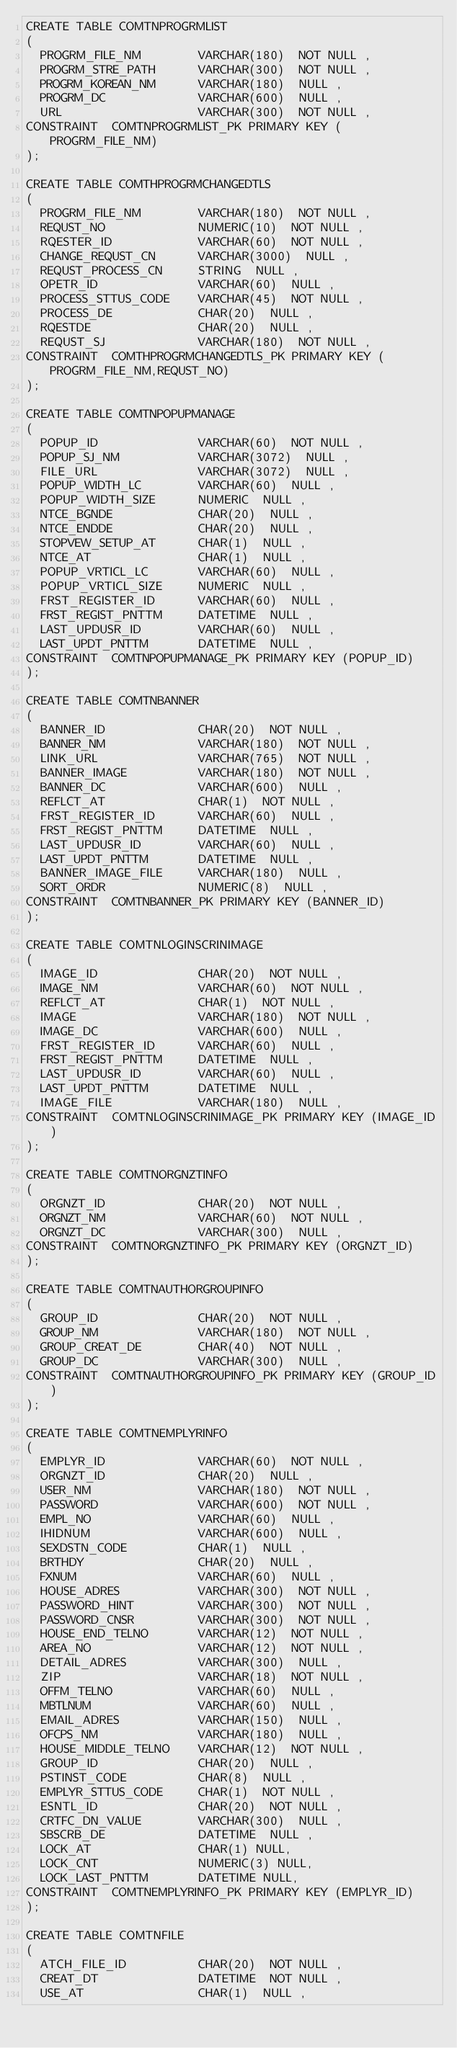<code> <loc_0><loc_0><loc_500><loc_500><_SQL_>CREATE TABLE COMTNPROGRMLIST
(
	PROGRM_FILE_NM        VARCHAR(180)  NOT NULL ,
	PROGRM_STRE_PATH      VARCHAR(300)  NOT NULL ,
	PROGRM_KOREAN_NM      VARCHAR(180)  NULL ,
	PROGRM_DC             VARCHAR(600)  NULL ,
	URL                   VARCHAR(300)  NOT NULL ,
CONSTRAINT  COMTNPROGRMLIST_PK PRIMARY KEY (PROGRM_FILE_NM)
);

CREATE TABLE COMTHPROGRMCHANGEDTLS
(
	PROGRM_FILE_NM        VARCHAR(180)  NOT NULL ,
	REQUST_NO             NUMERIC(10)  NOT NULL ,
	RQESTER_ID            VARCHAR(60)  NOT NULL ,
	CHANGE_REQUST_CN      VARCHAR(3000)  NULL ,
	REQUST_PROCESS_CN     STRING  NULL ,
	OPETR_ID              VARCHAR(60)  NULL ,
	PROCESS_STTUS_CODE    VARCHAR(45)  NOT NULL ,
	PROCESS_DE            CHAR(20)  NULL ,
	RQESTDE               CHAR(20)  NULL ,
	REQUST_SJ             VARCHAR(180)  NOT NULL ,
CONSTRAINT  COMTHPROGRMCHANGEDTLS_PK PRIMARY KEY (PROGRM_FILE_NM,REQUST_NO)
);

CREATE TABLE COMTNPOPUPMANAGE
(
	POPUP_ID              VARCHAR(60)  NOT NULL ,
	POPUP_SJ_NM           VARCHAR(3072)  NULL ,
	FILE_URL              VARCHAR(3072)  NULL ,
	POPUP_WIDTH_LC        VARCHAR(60)  NULL ,
	POPUP_WIDTH_SIZE      NUMERIC  NULL ,
	NTCE_BGNDE            CHAR(20)  NULL ,
	NTCE_ENDDE            CHAR(20)  NULL ,
	STOPVEW_SETUP_AT      CHAR(1)  NULL ,
	NTCE_AT               CHAR(1)  NULL ,
	POPUP_VRTICL_LC       VARCHAR(60)  NULL ,
	POPUP_VRTICL_SIZE     NUMERIC  NULL ,
	FRST_REGISTER_ID      VARCHAR(60)  NULL ,
	FRST_REGIST_PNTTM     DATETIME  NULL ,
	LAST_UPDUSR_ID        VARCHAR(60)  NULL ,
	LAST_UPDT_PNTTM       DATETIME  NULL ,
CONSTRAINT  COMTNPOPUPMANAGE_PK PRIMARY KEY (POPUP_ID)
);

CREATE TABLE COMTNBANNER
(
	BANNER_ID             CHAR(20)  NOT NULL ,
	BANNER_NM             VARCHAR(180)  NOT NULL ,
	LINK_URL              VARCHAR(765)  NOT NULL ,
	BANNER_IMAGE          VARCHAR(180)  NOT NULL ,
	BANNER_DC             VARCHAR(600)  NULL ,
	REFLCT_AT             CHAR(1)  NOT NULL ,
	FRST_REGISTER_ID      VARCHAR(60)  NULL ,
	FRST_REGIST_PNTTM     DATETIME  NULL ,
	LAST_UPDUSR_ID        VARCHAR(60)  NULL ,
	LAST_UPDT_PNTTM       DATETIME  NULL ,
	BANNER_IMAGE_FILE     VARCHAR(180)  NULL ,
	SORT_ORDR             NUMERIC(8)  NULL ,
CONSTRAINT  COMTNBANNER_PK PRIMARY KEY (BANNER_ID)
);

CREATE TABLE COMTNLOGINSCRINIMAGE
(
	IMAGE_ID              CHAR(20)  NOT NULL ,
	IMAGE_NM              VARCHAR(60)  NOT NULL ,
	REFLCT_AT             CHAR(1)  NOT NULL ,
	IMAGE                 VARCHAR(180)  NOT NULL ,
	IMAGE_DC              VARCHAR(600)  NULL ,
	FRST_REGISTER_ID      VARCHAR(60)  NULL ,
	FRST_REGIST_PNTTM     DATETIME  NULL ,
	LAST_UPDUSR_ID        VARCHAR(60)  NULL ,
	LAST_UPDT_PNTTM       DATETIME  NULL ,
	IMAGE_FILE            VARCHAR(180)  NULL ,
CONSTRAINT  COMTNLOGINSCRINIMAGE_PK PRIMARY KEY (IMAGE_ID)
);

CREATE TABLE COMTNORGNZTINFO
(
	ORGNZT_ID             CHAR(20)  NOT NULL ,
	ORGNZT_NM             VARCHAR(60)  NOT NULL ,
	ORGNZT_DC             VARCHAR(300)  NULL ,
CONSTRAINT  COMTNORGNZTINFO_PK PRIMARY KEY (ORGNZT_ID)
);

CREATE TABLE COMTNAUTHORGROUPINFO
(
	GROUP_ID              CHAR(20)  NOT NULL ,
	GROUP_NM              VARCHAR(180)  NOT NULL ,
	GROUP_CREAT_DE        CHAR(40)  NOT NULL ,
	GROUP_DC              VARCHAR(300)  NULL ,
CONSTRAINT  COMTNAUTHORGROUPINFO_PK PRIMARY KEY (GROUP_ID)
);

CREATE TABLE COMTNEMPLYRINFO
(
	EMPLYR_ID             VARCHAR(60)  NOT NULL ,
	ORGNZT_ID             CHAR(20)  NULL ,
	USER_NM               VARCHAR(180)  NOT NULL ,
	PASSWORD              VARCHAR(600)  NOT NULL ,
	EMPL_NO               VARCHAR(60)  NULL ,
	IHIDNUM               VARCHAR(600)  NULL ,
	SEXDSTN_CODE          CHAR(1)  NULL ,
	BRTHDY                CHAR(20)  NULL ,
	FXNUM                 VARCHAR(60)  NULL ,
	HOUSE_ADRES           VARCHAR(300)  NOT NULL ,
	PASSWORD_HINT         VARCHAR(300)  NOT NULL ,
	PASSWORD_CNSR         VARCHAR(300)  NOT NULL ,
	HOUSE_END_TELNO       VARCHAR(12)  NOT NULL ,
	AREA_NO               VARCHAR(12)  NOT NULL ,
	DETAIL_ADRES          VARCHAR(300)  NULL ,
	ZIP                   VARCHAR(18)  NOT NULL ,
	OFFM_TELNO            VARCHAR(60)  NULL ,
	MBTLNUM               VARCHAR(60)  NULL ,
	EMAIL_ADRES           VARCHAR(150)  NULL ,
	OFCPS_NM              VARCHAR(180)  NULL ,
	HOUSE_MIDDLE_TELNO    VARCHAR(12)  NOT NULL ,
	GROUP_ID              CHAR(20)  NULL ,
	PSTINST_CODE          CHAR(8)  NULL ,
	EMPLYR_STTUS_CODE     CHAR(1)  NOT NULL ,
	ESNTL_ID              CHAR(20)  NOT NULL ,
	CRTFC_DN_VALUE        VARCHAR(300)  NULL ,
	SBSCRB_DE             DATETIME  NULL ,
	LOCK_AT               CHAR(1) NULL,
	LOCK_CNT              NUMERIC(3) NULL,
	LOCK_LAST_PNTTM       DATETIME NULL,
CONSTRAINT  COMTNEMPLYRINFO_PK PRIMARY KEY (EMPLYR_ID)
);

CREATE TABLE COMTNFILE
(
	ATCH_FILE_ID          CHAR(20)  NOT NULL ,
	CREAT_DT              DATETIME  NOT NULL ,
	USE_AT                CHAR(1)  NULL ,</code> 